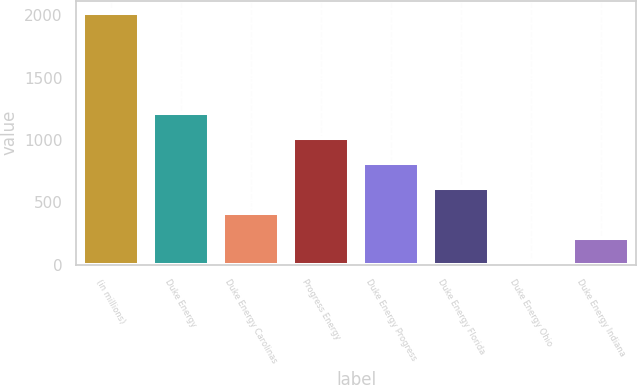Convert chart. <chart><loc_0><loc_0><loc_500><loc_500><bar_chart><fcel>(in millions)<fcel>Duke Energy<fcel>Duke Energy Carolinas<fcel>Progress Energy<fcel>Duke Energy Progress<fcel>Duke Energy Florida<fcel>Duke Energy Ohio<fcel>Duke Energy Indiana<nl><fcel>2017<fcel>1216.2<fcel>415.4<fcel>1016<fcel>815.8<fcel>615.6<fcel>15<fcel>215.2<nl></chart> 